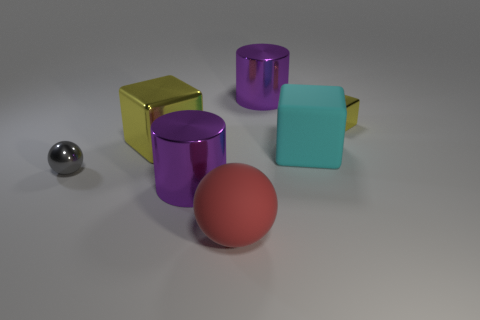Can you describe the lighting and the setting of the scene? The image has a soft and diffused lighting that casts gentle shadows on a grey floor. The shadows suggest a light source from the top left, subtly illuminating the scene without causing harsh highlights. The background is neutral and nondescript, focusing attention on the objects themselves. This minimalist setting creates a calm atmosphere and allows for clear observation of the objects' colors, shapes, and textures. 